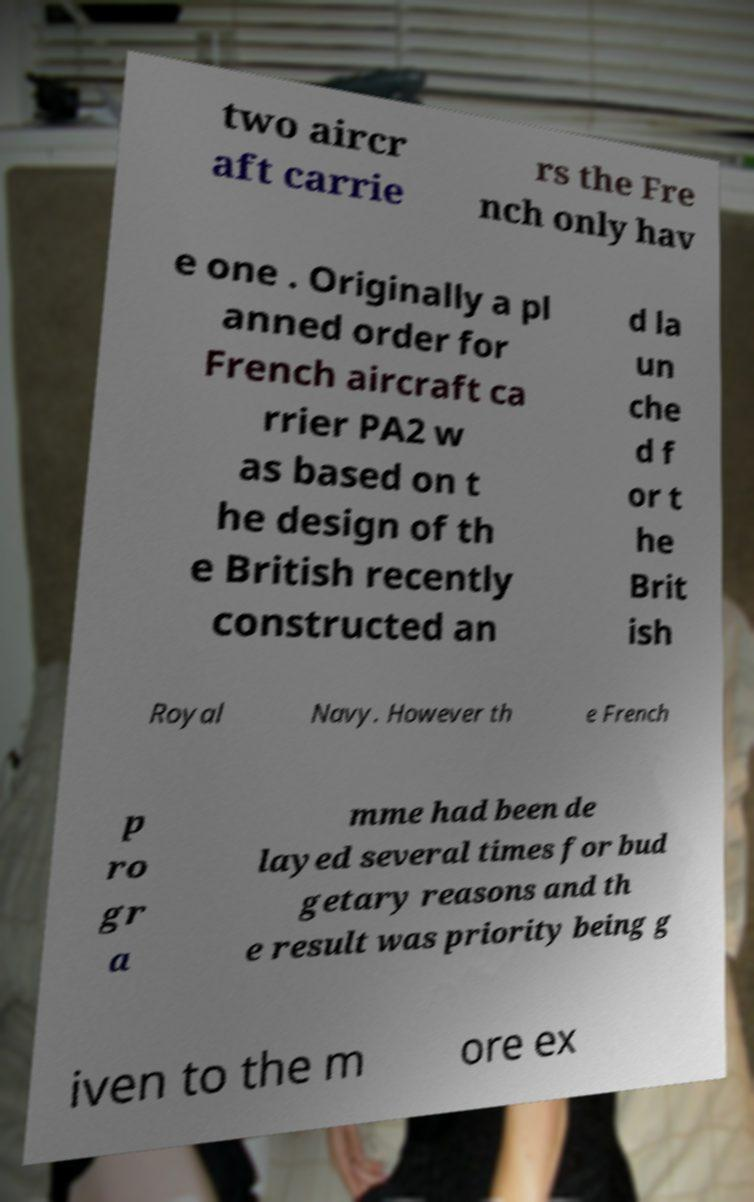Can you accurately transcribe the text from the provided image for me? two aircr aft carrie rs the Fre nch only hav e one . Originally a pl anned order for French aircraft ca rrier PA2 w as based on t he design of th e British recently constructed an d la un che d f or t he Brit ish Royal Navy. However th e French p ro gr a mme had been de layed several times for bud getary reasons and th e result was priority being g iven to the m ore ex 